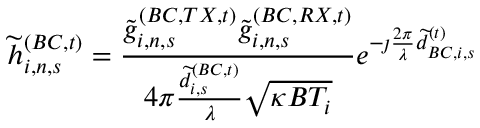<formula> <loc_0><loc_0><loc_500><loc_500>\widetilde { h } _ { i , n , s } ^ { ( B C , t ) } = \frac { \widetilde { g } _ { i , n , s } ^ { ( B C , T X , t ) } \widetilde { g } _ { i , n , s } ^ { ( B C , R X , t ) } } { 4 \pi \frac { \widetilde { d } _ { i , s } ^ { ( B C , t ) } } { \lambda } \sqrt { \kappa B T _ { i } } } e ^ { - \jmath \frac { 2 \pi } { \lambda } \widetilde { d } _ { B C , i , s } ^ { ( t ) } }</formula> 